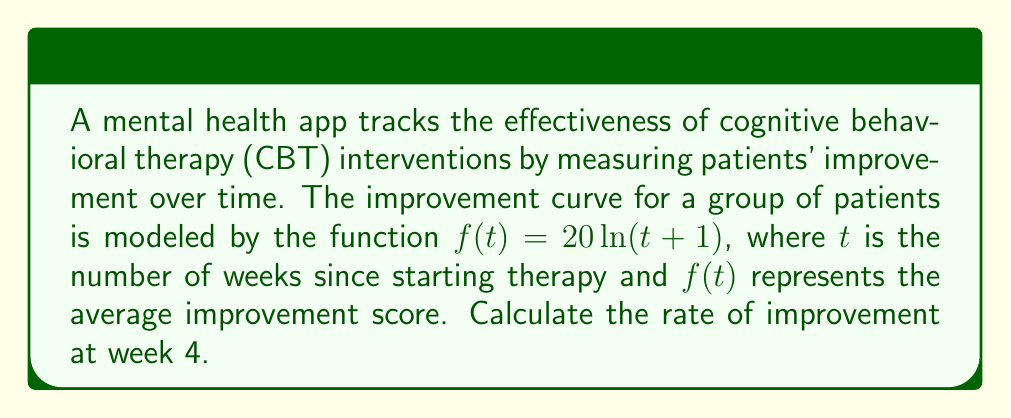Can you solve this math problem? To find the rate of improvement at week 4, we need to calculate the derivative of the function $f(t)$ and evaluate it at $t=4$. Let's follow these steps:

1) The given function is $f(t) = 20\ln(t+1)$

2) To find the derivative, we use the chain rule:
   $$f'(t) = 20 \cdot \frac{d}{dt}[\ln(t+1)]$$

3) The derivative of $\ln(x)$ is $\frac{1}{x}$, so:
   $$f'(t) = 20 \cdot \frac{1}{t+1}$$

4) Now we evaluate $f'(t)$ at $t=4$:
   $$f'(4) = 20 \cdot \frac{1}{4+1} = 20 \cdot \frac{1}{5} = 4$$

5) Therefore, the rate of improvement at week 4 is 4 units per week.

This result indicates that after 4 weeks of CBT, patients are improving at a rate of 4 points per week on the improvement scale used by the app.
Answer: $4$ units per week 